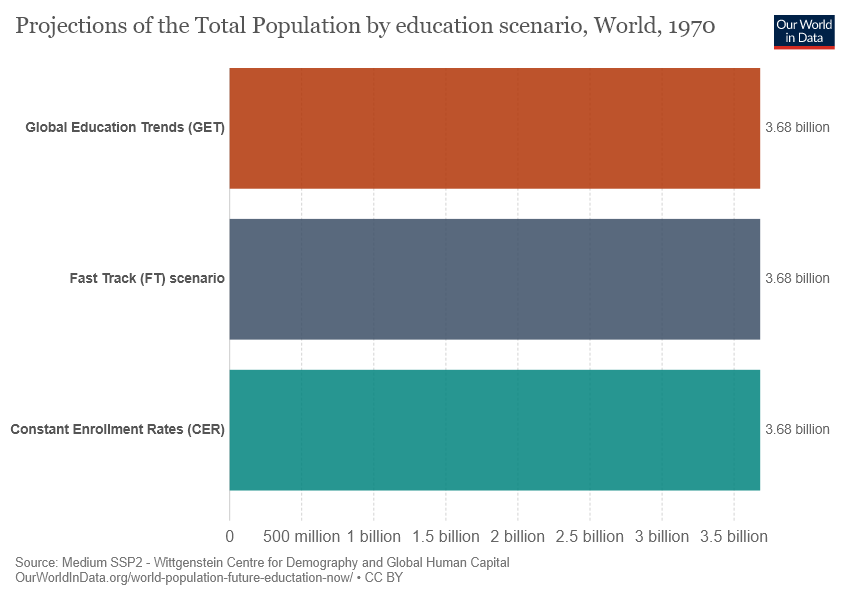Identify some key points in this picture. Thirty-three percent of bars display the same value. The value of all the bars is the same and equal to 3.68. 